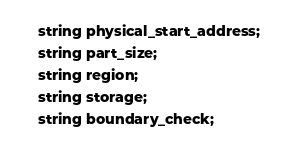Convert code to text. <code><loc_0><loc_0><loc_500><loc_500><_C_>	string physical_start_address;
	string part_size;
	string region;
	string storage;
	string boundary_check;</code> 